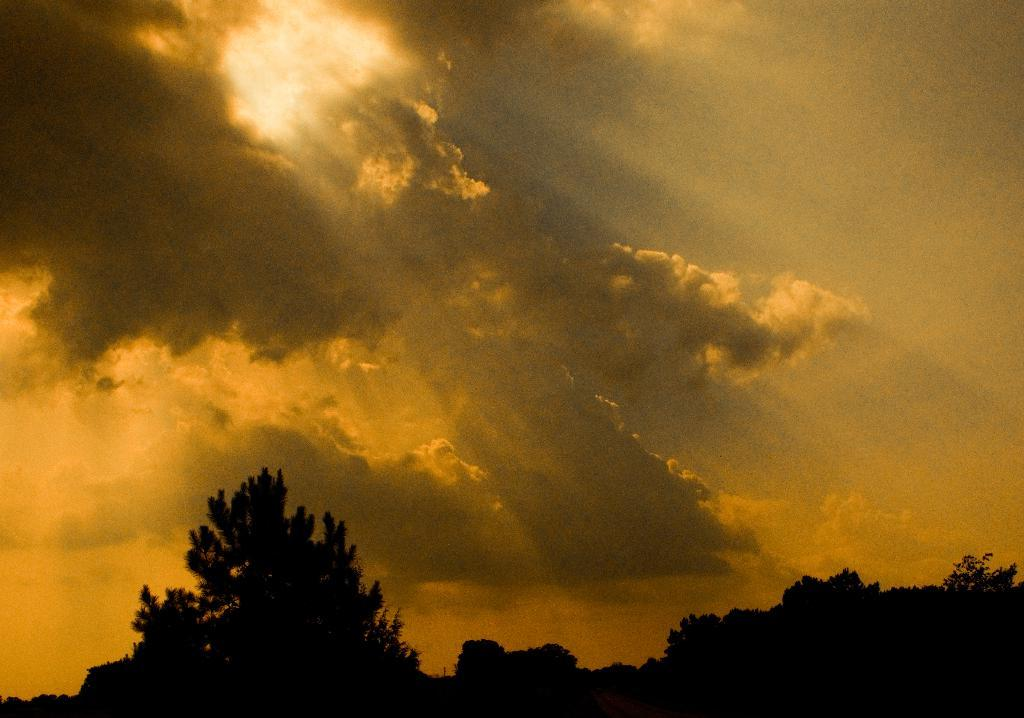What type of vegetation can be seen in the image? There are trees in the image. What is visible in the background of the image? The sky is visible in the background of the image. What can be observed in the sky? Clouds are present in the sky. What is the color of the sky in the image? The sky appears to be yellow in color. Can you see a plane flying in the image? There is no mention of a plane in the image or the provided facts. 